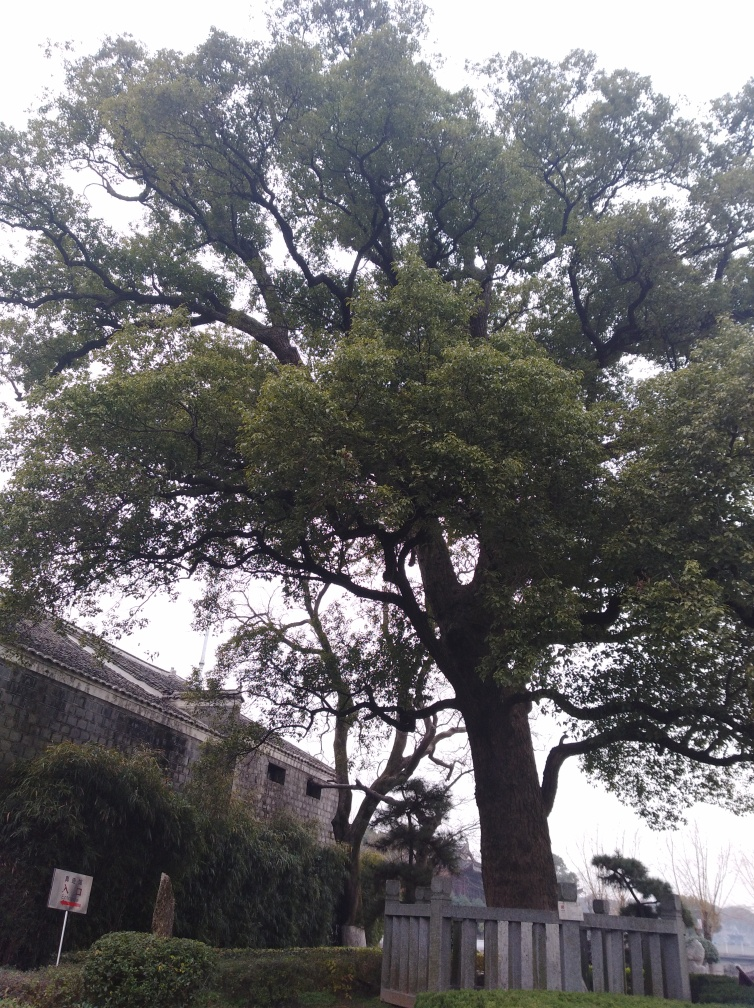What historical period might the stone structure belong to? While it's not possible to give an exact period without more context, the stone wall construction suggests it could be part of a historical fortification or building. Such structures often range from medieval times up to the 19th century, depending on their design and regional history. 